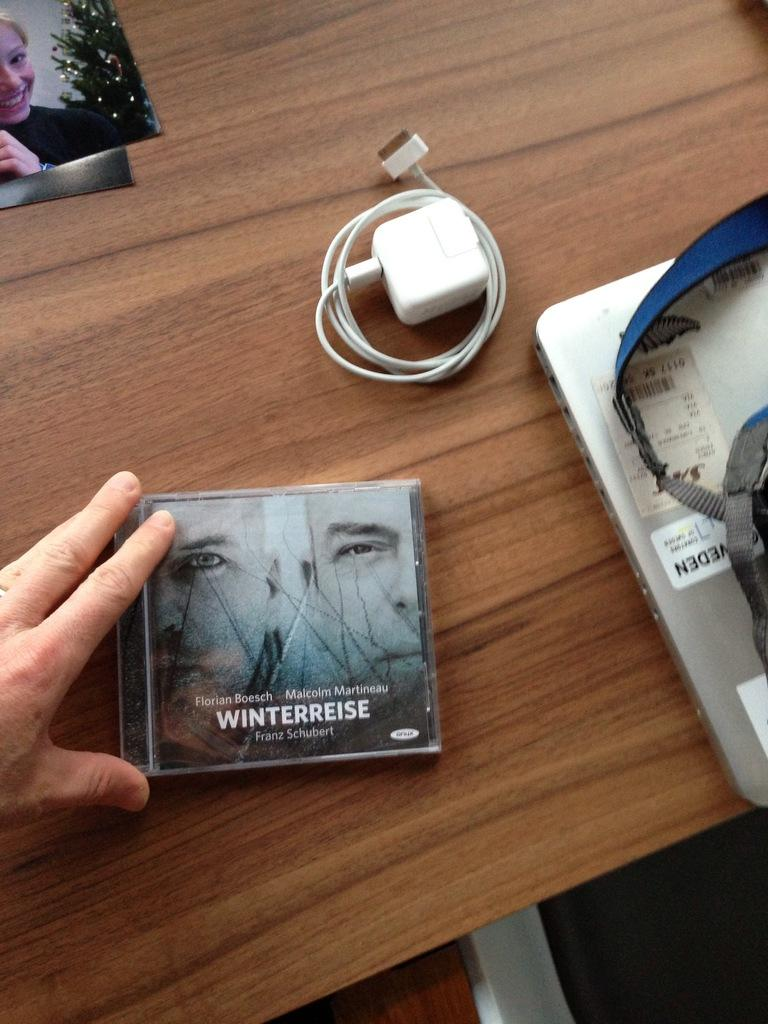<image>
Relay a brief, clear account of the picture shown. A CD case that says Winterreise is on a wooden table next to a laptop. 